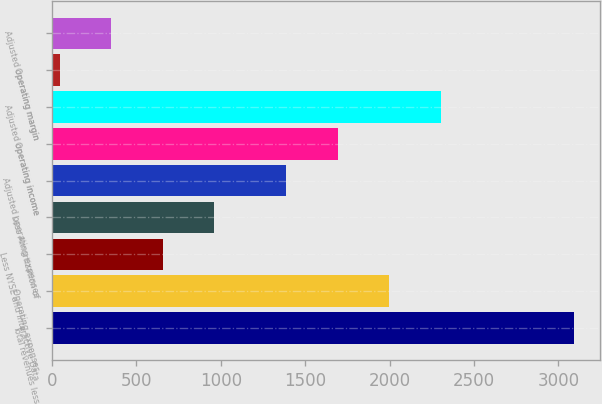<chart> <loc_0><loc_0><loc_500><loc_500><bar_chart><fcel>Total revenues less<fcel>Operating expenses<fcel>Less NYSE and Interactive Data<fcel>Less Amortization of<fcel>Adjusted operating expenses<fcel>Operating income<fcel>Adjusted operating income<fcel>Operating margin<fcel>Adjusted operating margin<nl><fcel>3092<fcel>1998<fcel>656<fcel>960.5<fcel>1389<fcel>1693.5<fcel>2302.5<fcel>47<fcel>351.5<nl></chart> 